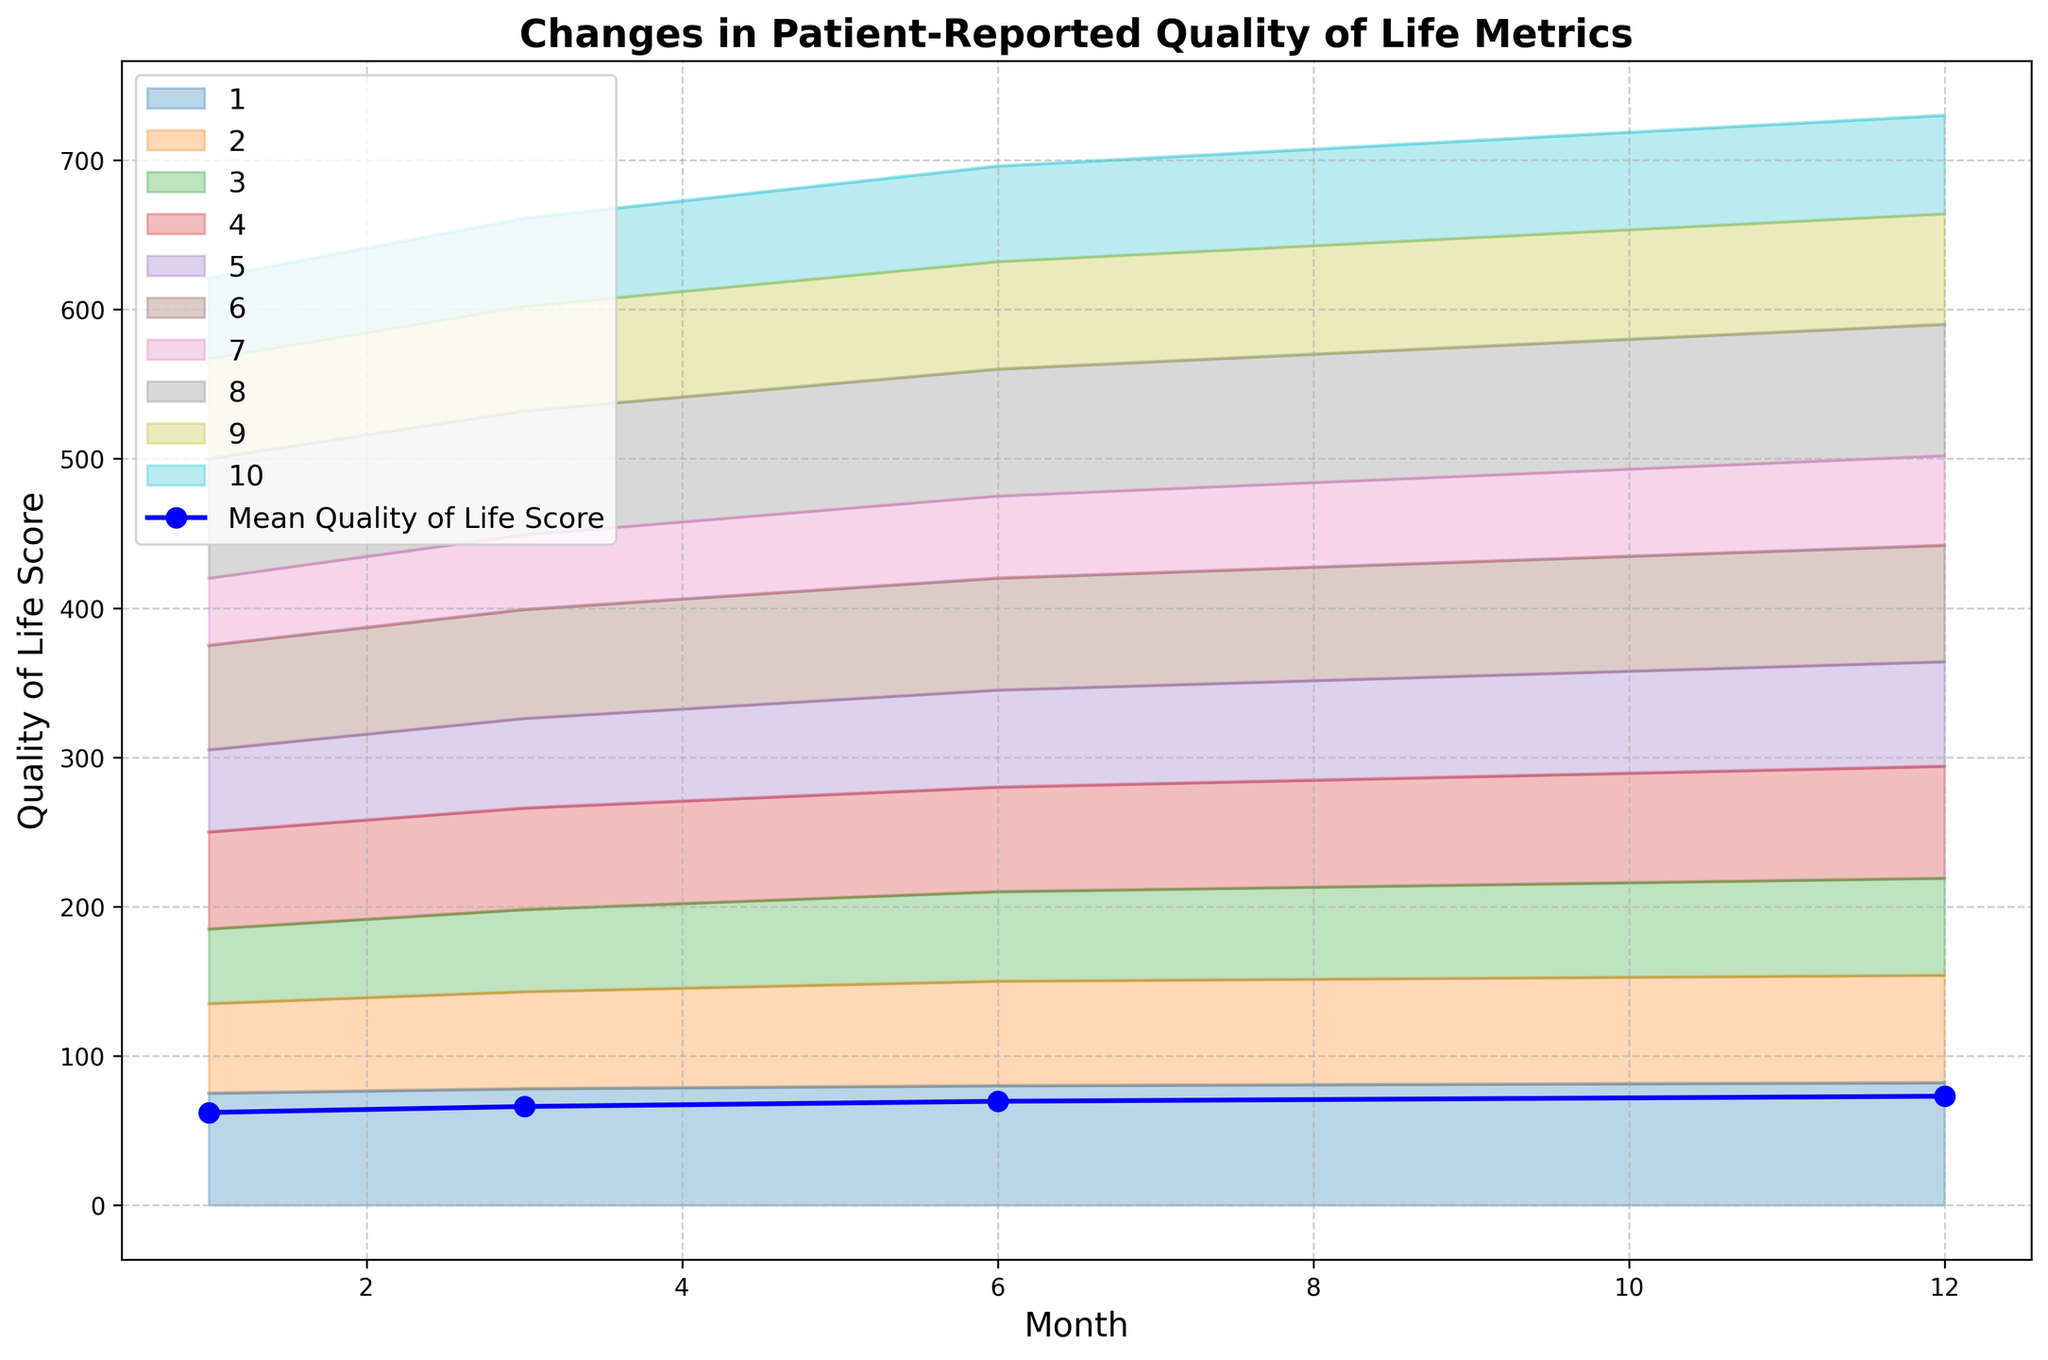What trend can be observed in the mean Quality of Life Score over the months? The mean Quality of Life Score increases steadily from month 1 to month 12. This can be seen by the positive slope of the blue line representing the mean score.
Answer: Increasing trend Which patient had the highest Quality of Life Score at month 12? At month 12, Patient 8 had the highest Quality of Life Score. This is observed by identifying the highest area segment for month 12.
Answer: Patient 8 Compare the Quality of Life Scores between month 6 and month 1. Is there an overall improvement? At month 1, the mean score is lower than at month 6. Observing the area chart and the blue line, which shows an upward trend between these months, confirms an overall improvement.
Answer: Yes, there is an improvement What is the average Quality of Life Score at month 12? By looking at the blue line's value at month 12 and cross-referencing with the y-axis, the average Quality of Life Score is approximately 73-74.
Answer: Around 73-74 How does Patient 1’s Quality of Life Score change from month 1 to month 12? Patient 1’s Quality of Life Score increased from 75 at month 1 to 82 at month 12. This is observed by following the area for Patient 1 over the months.
Answer: Increase of 7 points Which month shows the largest increase in mean Quality of Life Score compared to the previous month? By comparing the blue line's slope between months, the largest positive change is between month 3 and month 6.
Answer: Between month 3 and month 6 Are there any patients who reported a decrease in their Quality of Life Score at any point? Observing individual areas, all patients show an increasing trend without any noticeable dips, so no decreases were reported.
Answer: No Which patient showed the least improvement in Quality of Life Score from month 1 to month 12? Patient 7 shows the least improvement, with scores increasing from 45 to 60. This is identified by comparing the total changes for each patient’s area.
Answer: Patient 7 